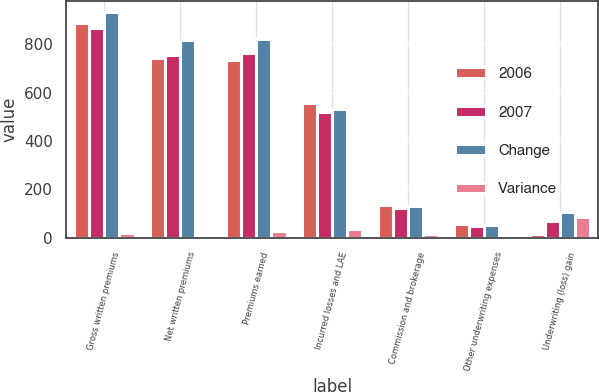Convert chart. <chart><loc_0><loc_0><loc_500><loc_500><stacked_bar_chart><ecel><fcel>Gross written premiums<fcel>Net written premiums<fcel>Premiums earned<fcel>Incurred losses and LAE<fcel>Commission and brokerage<fcel>Other underwriting expenses<fcel>Underwriting (loss) gain<nl><fcel>2006<fcel>885.6<fcel>744.3<fcel>735.9<fcel>556.4<fcel>136.2<fcel>58.2<fcel>14.9<nl><fcel>2007<fcel>866.3<fcel>753.3<fcel>761.7<fcel>519.9<fcel>123.1<fcel>48.9<fcel>69.8<nl><fcel>Change<fcel>932.5<fcel>815.3<fcel>823<fcel>530.8<fcel>132.6<fcel>51.9<fcel>107.7<nl><fcel>Variance<fcel>19.3<fcel>9<fcel>25.8<fcel>36.5<fcel>13.1<fcel>9.3<fcel>84.7<nl></chart> 